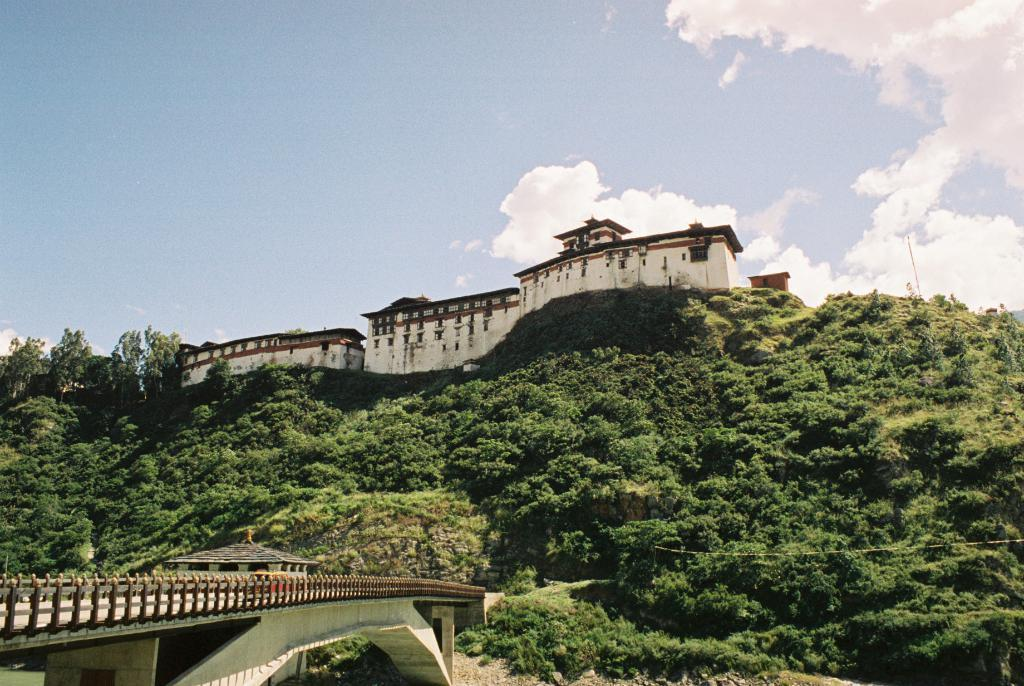What is located on top of the mountain in the image? There is a monument on top of a mountain in the image. What can be seen on the bottom left of the image? There is a bridge on the bottom left of the image. What is visible at the top of the image? The sky is visible at the top of the image. What can be observed in the sky? Clouds are present in the sky. What type of vegetation is present in the image? There are many trees in the image. Where is the cushion located in the image? There is no cushion present in the image. What type of stove can be seen near the bridge in the image? There is no stove present in the image. 